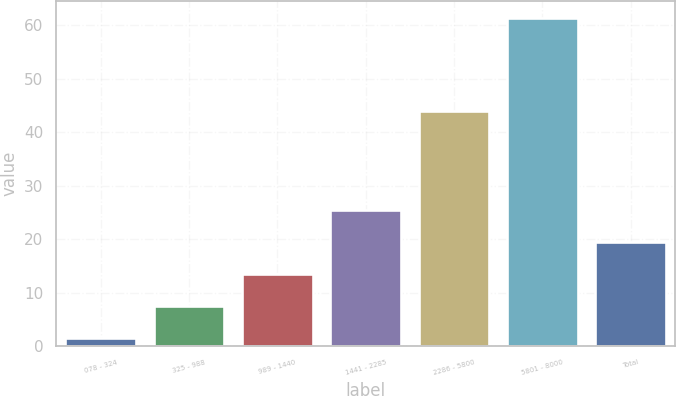Convert chart. <chart><loc_0><loc_0><loc_500><loc_500><bar_chart><fcel>078 - 324<fcel>325 - 988<fcel>989 - 1440<fcel>1441 - 2285<fcel>2286 - 5800<fcel>5801 - 8000<fcel>Total<nl><fcel>1.6<fcel>7.58<fcel>13.56<fcel>25.52<fcel>44.06<fcel>61.42<fcel>19.54<nl></chart> 